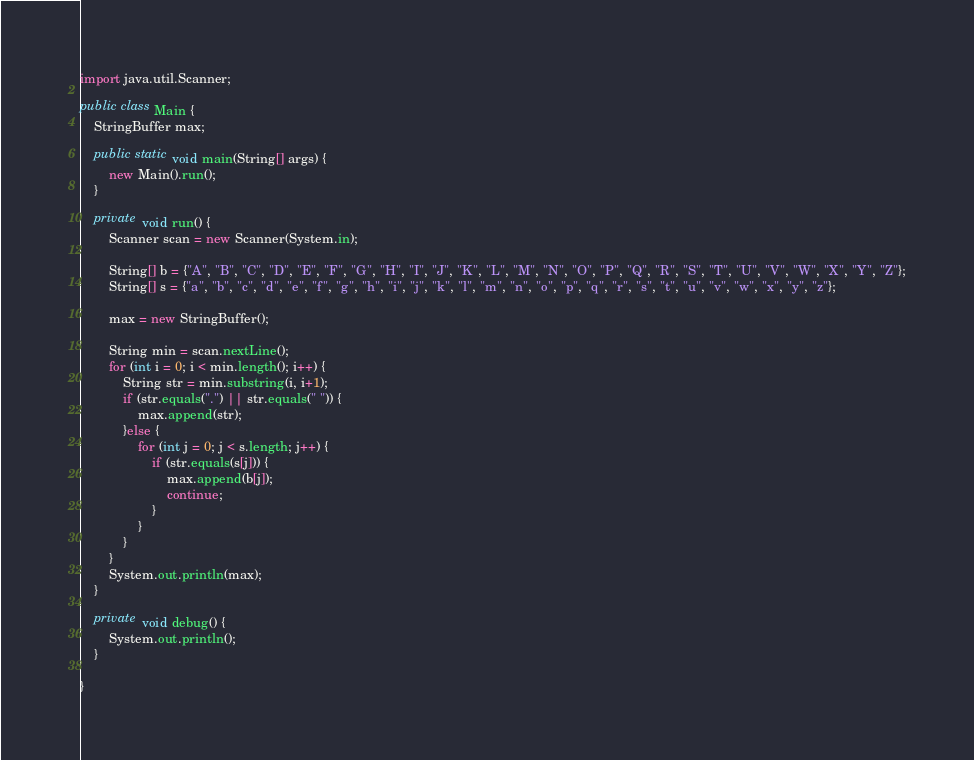<code> <loc_0><loc_0><loc_500><loc_500><_Java_>import java.util.Scanner;

public class Main {
	StringBuffer max;

	public static void main(String[] args) {
		new Main().run();
	}
	
	private void run() {
		Scanner scan = new Scanner(System.in);
		
		String[] b = {"A", "B", "C", "D", "E", "F", "G", "H", "I", "J", "K", "L", "M", "N", "O", "P", "Q", "R", "S", "T", "U", "V", "W", "X", "Y", "Z"};
		String[] s = {"a", "b", "c", "d", "e", "f", "g", "h", "i", "j", "k", "l", "m", "n", "o", "p", "q", "r", "s", "t", "u", "v", "w", "x", "y", "z"};
		
		max = new StringBuffer();
		
		String min = scan.nextLine();
		for (int i = 0; i < min.length(); i++) {
			String str = min.substring(i, i+1);
			if (str.equals(".") || str.equals(" ")) {
				max.append(str);
			}else {
				for (int j = 0; j < s.length; j++) {
					if (str.equals(s[j])) {
						max.append(b[j]);
						continue;
					}
				}
			}
		}
		System.out.println(max);
	}
	
	private void debug() {
		System.out.println();
	}

}</code> 